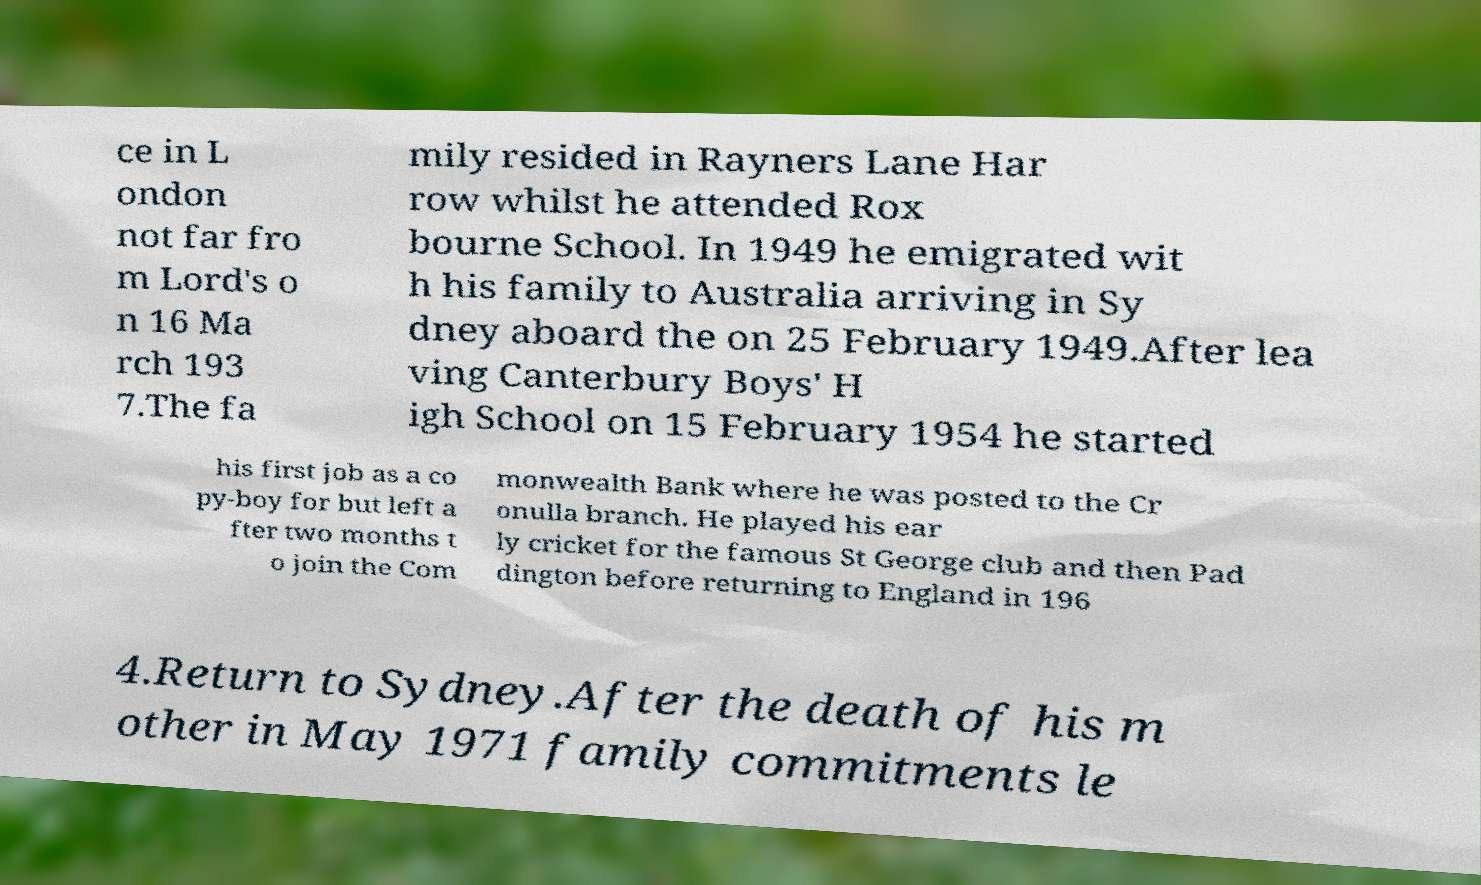Please identify and transcribe the text found in this image. ce in L ondon not far fro m Lord's o n 16 Ma rch 193 7.The fa mily resided in Rayners Lane Har row whilst he attended Rox bourne School. In 1949 he emigrated wit h his family to Australia arriving in Sy dney aboard the on 25 February 1949.After lea ving Canterbury Boys' H igh School on 15 February 1954 he started his first job as a co py-boy for but left a fter two months t o join the Com monwealth Bank where he was posted to the Cr onulla branch. He played his ear ly cricket for the famous St George club and then Pad dington before returning to England in 196 4.Return to Sydney.After the death of his m other in May 1971 family commitments le 